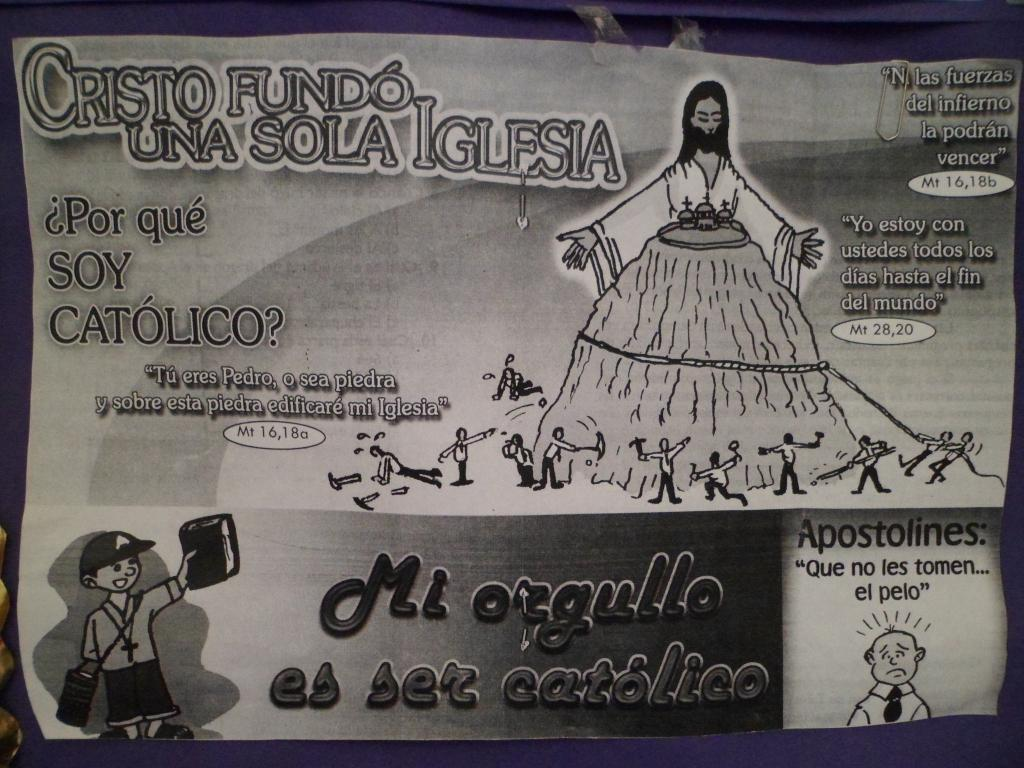What is present in the image that contains visuals and text? There is a poster in the image that contains pictures and writing. Can you describe the pictures on the poster? Unfortunately, the specific pictures on the poster cannot be described without more information. What type of information is conveyed through the writing on the poster? The content of the writing on the poster cannot be determined without more information. What channel is the mother using to navigate the map in the image? There is no channel, mother, or map present in the image. 